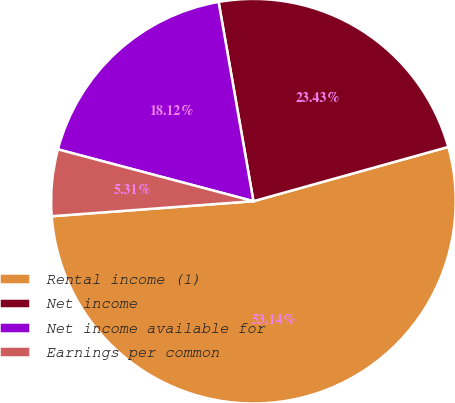<chart> <loc_0><loc_0><loc_500><loc_500><pie_chart><fcel>Rental income (1)<fcel>Net income<fcel>Net income available for<fcel>Earnings per common<nl><fcel>53.14%<fcel>23.43%<fcel>18.12%<fcel>5.31%<nl></chart> 